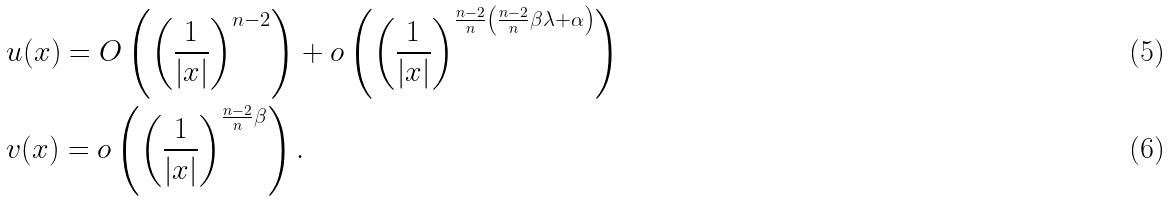<formula> <loc_0><loc_0><loc_500><loc_500>& u ( x ) = O \left ( \left ( \frac { 1 } { | x | } \right ) ^ { n - 2 } \right ) + o \left ( \left ( \frac { 1 } { | x | } \right ) ^ { \frac { n - 2 } { n } \left ( \frac { n - 2 } { n } \beta \lambda + \alpha \right ) } \right ) \\ & v ( x ) = o \left ( \left ( \frac { 1 } { | x | } \right ) ^ { \frac { n - 2 } { n } \beta } \right ) .</formula> 